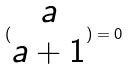<formula> <loc_0><loc_0><loc_500><loc_500>( \begin{matrix} a \\ a + 1 \end{matrix} ) = 0</formula> 